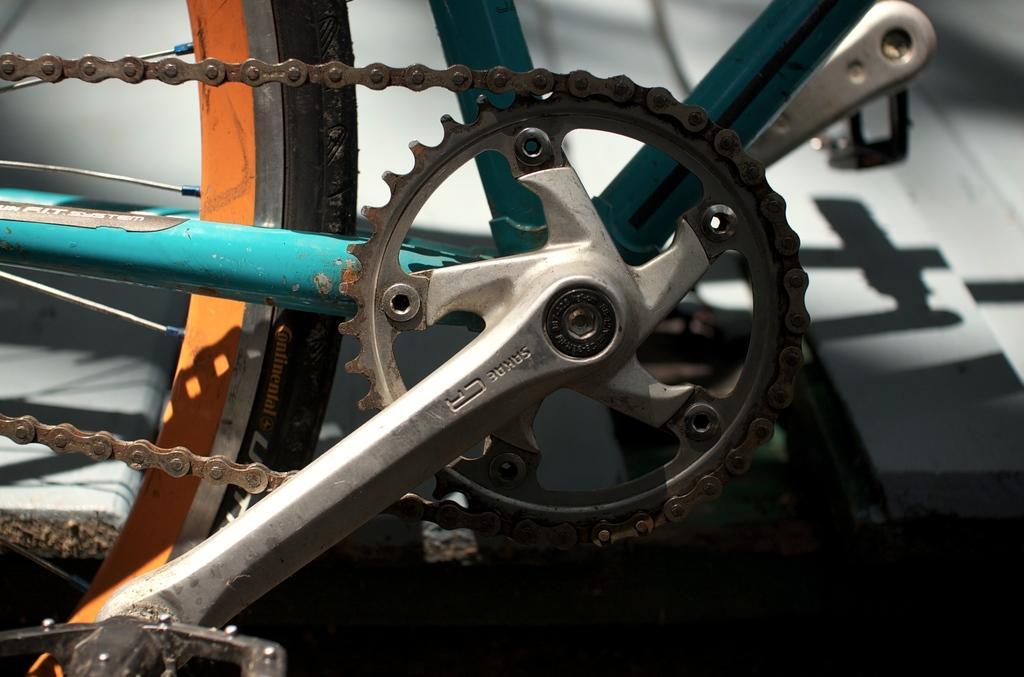In one or two sentences, can you explain what this image depicts? In this image we can see a Tyre, chain and pedals of a bicycle. 